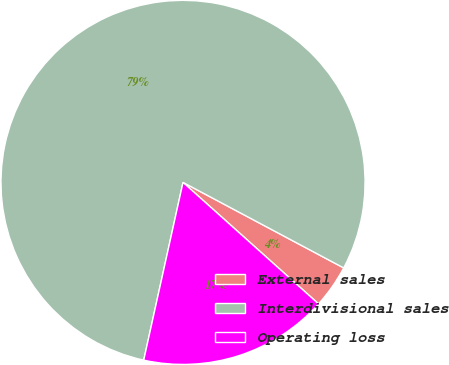<chart> <loc_0><loc_0><loc_500><loc_500><pie_chart><fcel>External sales<fcel>Interdivisional sales<fcel>Operating loss<nl><fcel>3.85%<fcel>79.33%<fcel>16.83%<nl></chart> 